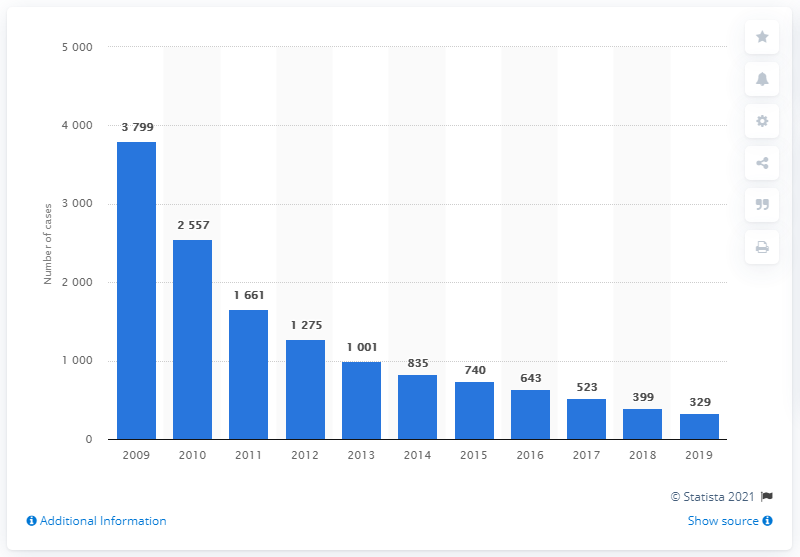Identify some key points in this picture. There were 329 reported cases of robbery in Taiwan in 2019. 